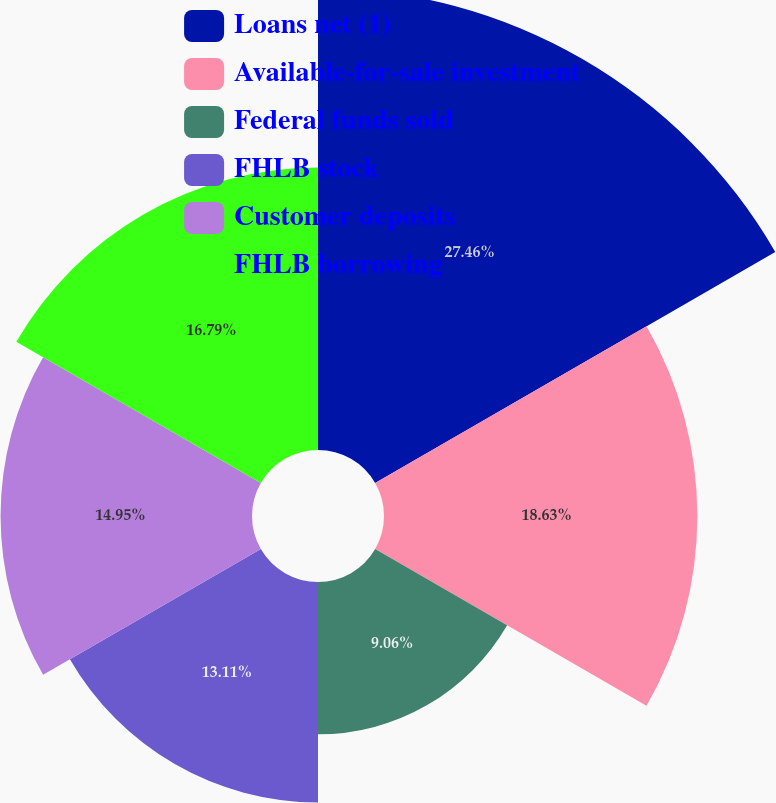Convert chart. <chart><loc_0><loc_0><loc_500><loc_500><pie_chart><fcel>Loans net (1)<fcel>Available-for-sale investment<fcel>Federal funds sold<fcel>FHLB stock<fcel>Customer deposits<fcel>FHLB borrowing<nl><fcel>27.47%<fcel>18.63%<fcel>9.06%<fcel>13.11%<fcel>14.95%<fcel>16.79%<nl></chart> 